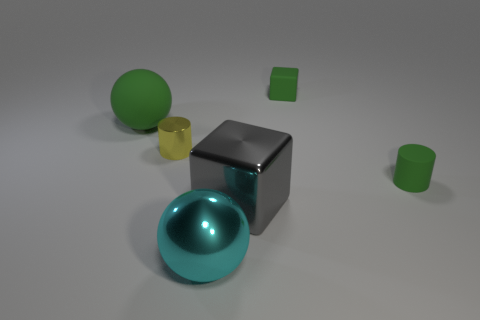What textures are visible on the objects? The objects appear to have smooth surfaces with subtle reflections, indicating a somewhat glossy texture. 